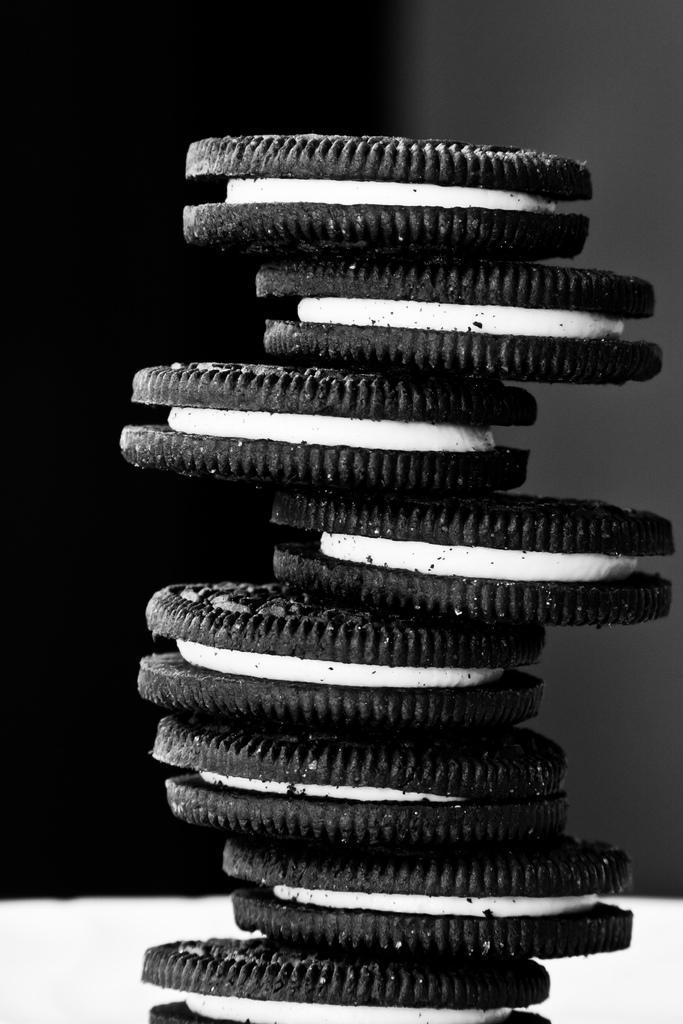How would you summarize this image in a sentence or two? In this picture there are biscuits. At the bottom it looks like a plate. At the back there is a black and grey color background. 